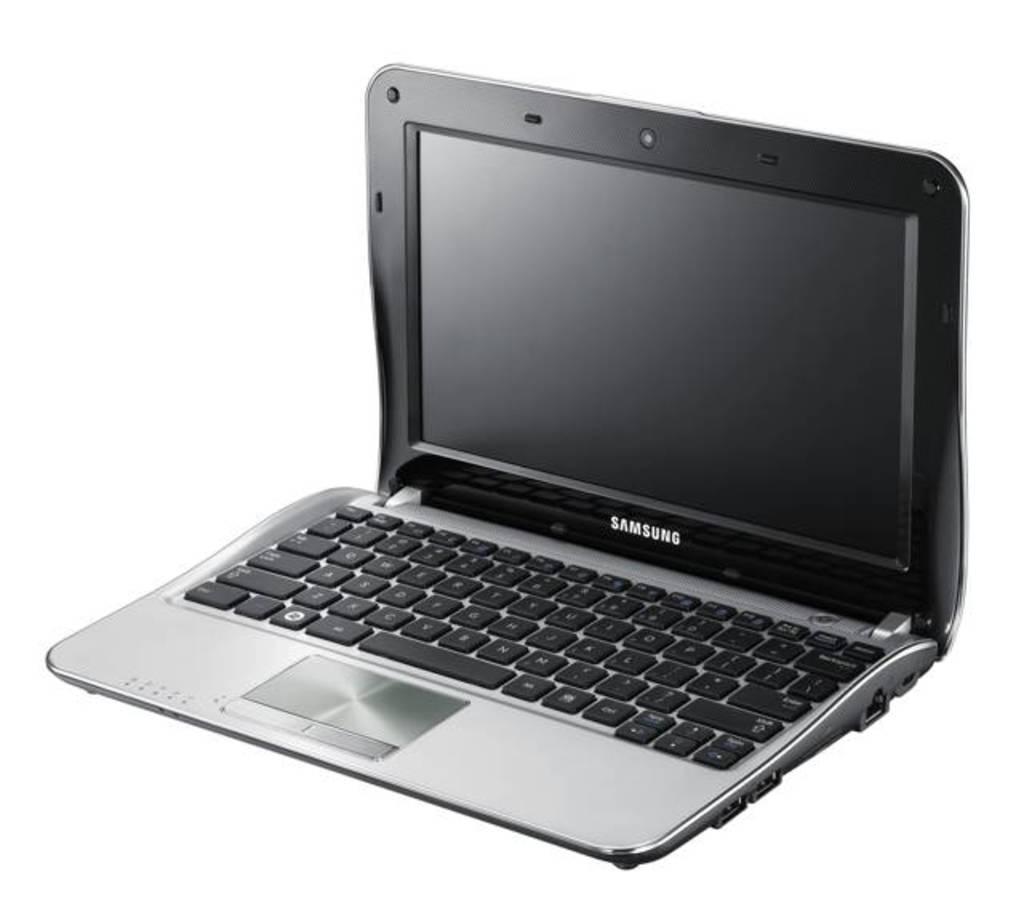Which company made this laptop?
Your response must be concise. Samsung. 